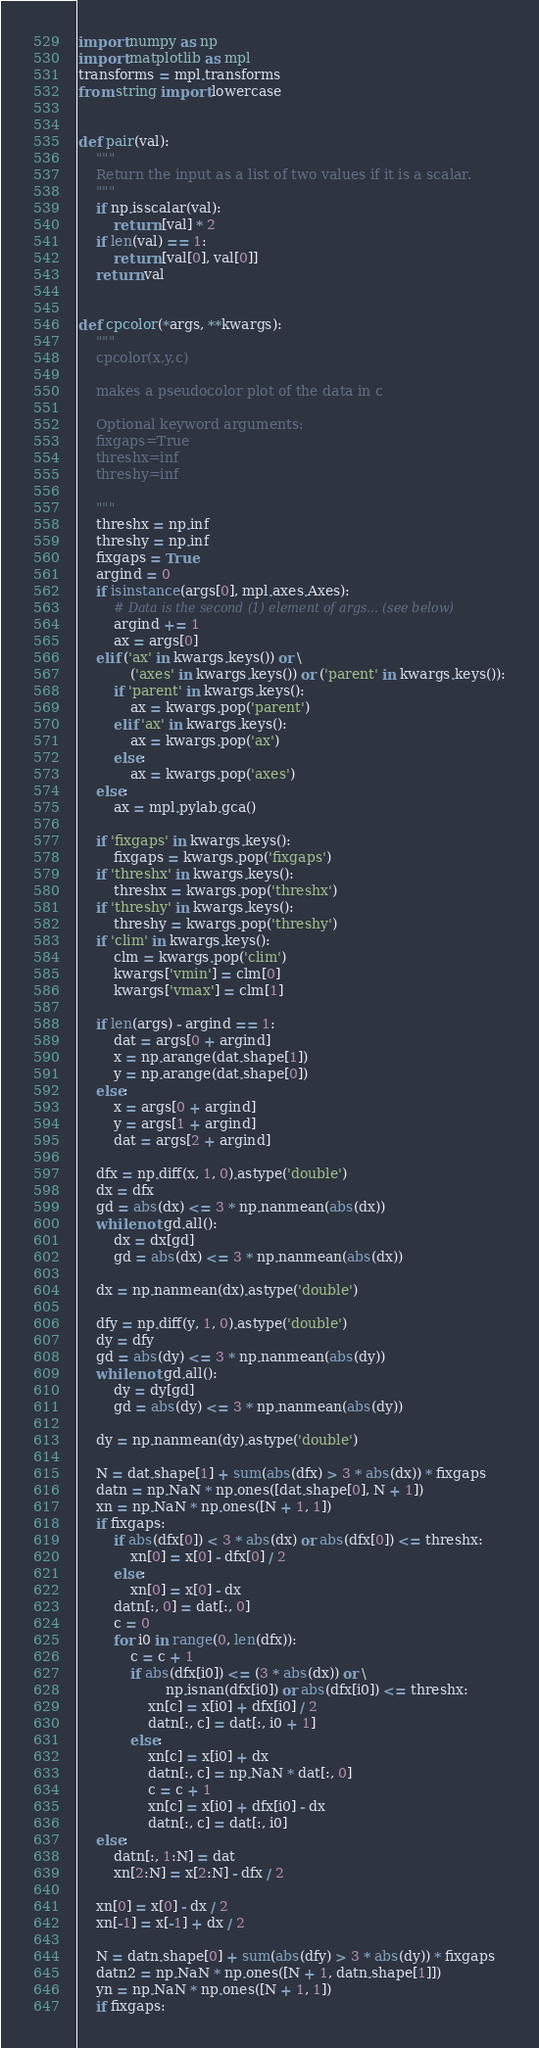Convert code to text. <code><loc_0><loc_0><loc_500><loc_500><_Python_>import numpy as np
import matplotlib as mpl
transforms = mpl.transforms
from string import lowercase


def pair(val):
    """
    Return the input as a list of two values if it is a scalar.
    """
    if np.isscalar(val):
        return [val] * 2
    if len(val) == 1:
        return [val[0], val[0]]
    return val


def cpcolor(*args, **kwargs):
    """
    cpcolor(x,y,c)

    makes a pseudocolor plot of the data in c

    Optional keyword arguments:
    fixgaps=True
    threshx=inf
    threshy=inf

    """
    threshx = np.inf
    threshy = np.inf
    fixgaps = True
    argind = 0
    if isinstance(args[0], mpl.axes.Axes):
        # Data is the second (1) element of args... (see below)
        argind += 1
        ax = args[0]
    elif ('ax' in kwargs.keys()) or \
            ('axes' in kwargs.keys()) or ('parent' in kwargs.keys()):
        if 'parent' in kwargs.keys():
            ax = kwargs.pop('parent')
        elif 'ax' in kwargs.keys():
            ax = kwargs.pop('ax')
        else:
            ax = kwargs.pop('axes')
    else:
        ax = mpl.pylab.gca()

    if 'fixgaps' in kwargs.keys():
        fixgaps = kwargs.pop('fixgaps')
    if 'threshx' in kwargs.keys():
        threshx = kwargs.pop('threshx')
    if 'threshy' in kwargs.keys():
        threshy = kwargs.pop('threshy')
    if 'clim' in kwargs.keys():
        clm = kwargs.pop('clim')
        kwargs['vmin'] = clm[0]
        kwargs['vmax'] = clm[1]

    if len(args) - argind == 1:
        dat = args[0 + argind]
        x = np.arange(dat.shape[1])
        y = np.arange(dat.shape[0])
    else:
        x = args[0 + argind]
        y = args[1 + argind]
        dat = args[2 + argind]

    dfx = np.diff(x, 1, 0).astype('double')
    dx = dfx
    gd = abs(dx) <= 3 * np.nanmean(abs(dx))
    while not gd.all():
        dx = dx[gd]
        gd = abs(dx) <= 3 * np.nanmean(abs(dx))

    dx = np.nanmean(dx).astype('double')

    dfy = np.diff(y, 1, 0).astype('double')
    dy = dfy
    gd = abs(dy) <= 3 * np.nanmean(abs(dy))
    while not gd.all():
        dy = dy[gd]
        gd = abs(dy) <= 3 * np.nanmean(abs(dy))

    dy = np.nanmean(dy).astype('double')

    N = dat.shape[1] + sum(abs(dfx) > 3 * abs(dx)) * fixgaps
    datn = np.NaN * np.ones([dat.shape[0], N + 1])
    xn = np.NaN * np.ones([N + 1, 1])
    if fixgaps:
        if abs(dfx[0]) < 3 * abs(dx) or abs(dfx[0]) <= threshx:
            xn[0] = x[0] - dfx[0] / 2
        else:
            xn[0] = x[0] - dx
        datn[:, 0] = dat[:, 0]
        c = 0
        for i0 in range(0, len(dfx)):
            c = c + 1
            if abs(dfx[i0]) <= (3 * abs(dx)) or \
                    np.isnan(dfx[i0]) or abs(dfx[i0]) <= threshx:
                xn[c] = x[i0] + dfx[i0] / 2
                datn[:, c] = dat[:, i0 + 1]
            else:
                xn[c] = x[i0] + dx
                datn[:, c] = np.NaN * dat[:, 0]
                c = c + 1
                xn[c] = x[i0] + dfx[i0] - dx
                datn[:, c] = dat[:, i0]
    else:
        datn[:, 1:N] = dat
        xn[2:N] = x[2:N] - dfx / 2

    xn[0] = x[0] - dx / 2
    xn[-1] = x[-1] + dx / 2

    N = datn.shape[0] + sum(abs(dfy) > 3 * abs(dy)) * fixgaps
    datn2 = np.NaN * np.ones([N + 1, datn.shape[1]])
    yn = np.NaN * np.ones([N + 1, 1])
    if fixgaps:</code> 